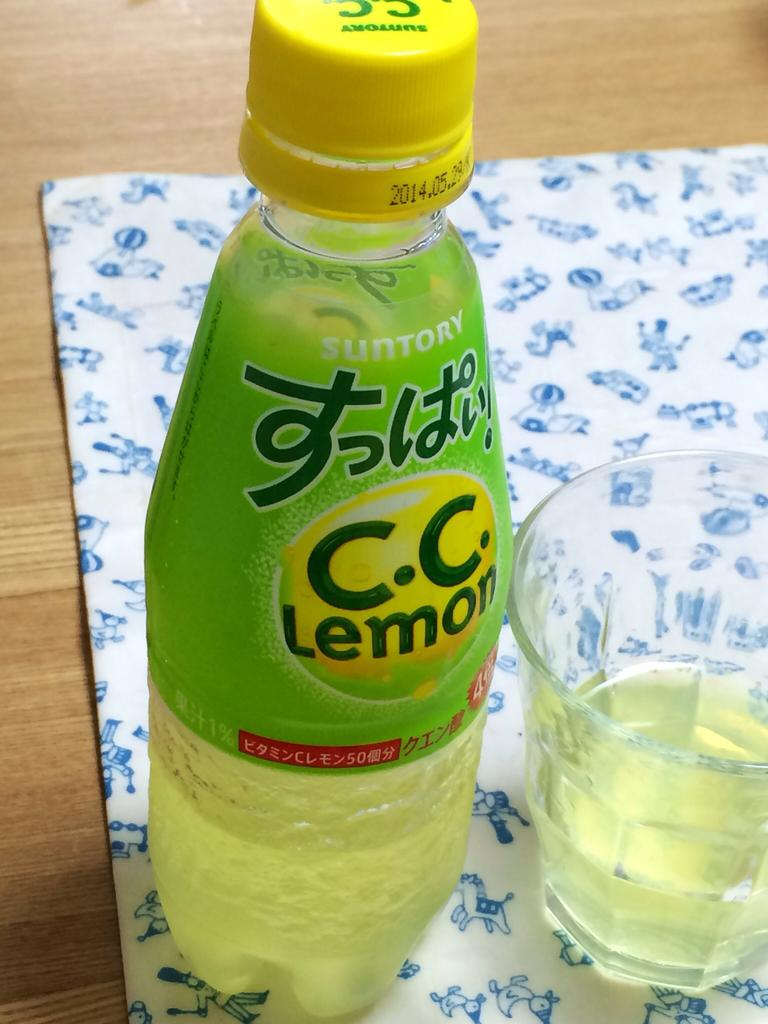What type of table is in the image? There is a wooden table in the image. What is covering the table? There is a cloth on the table. What objects are on the table? There is a lemon bottle and a glass on the table. What type of baseball is depicted on the table in the image? There is no baseball present in the image; it features a wooden table with a cloth, a lemon bottle, and a glass. What legal advice is being given by the lawyer in the image? There is no lawyer present in the image; it features a wooden table with a cloth, a lemon bottle, and a glass. 